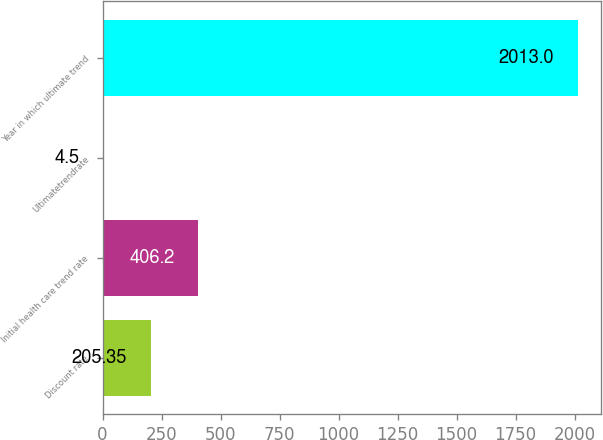Convert chart to OTSL. <chart><loc_0><loc_0><loc_500><loc_500><bar_chart><fcel>Discount rate<fcel>Initial health care trend rate<fcel>Ultimatetrendrate<fcel>Year in which ultimate trend<nl><fcel>205.35<fcel>406.2<fcel>4.5<fcel>2013<nl></chart> 